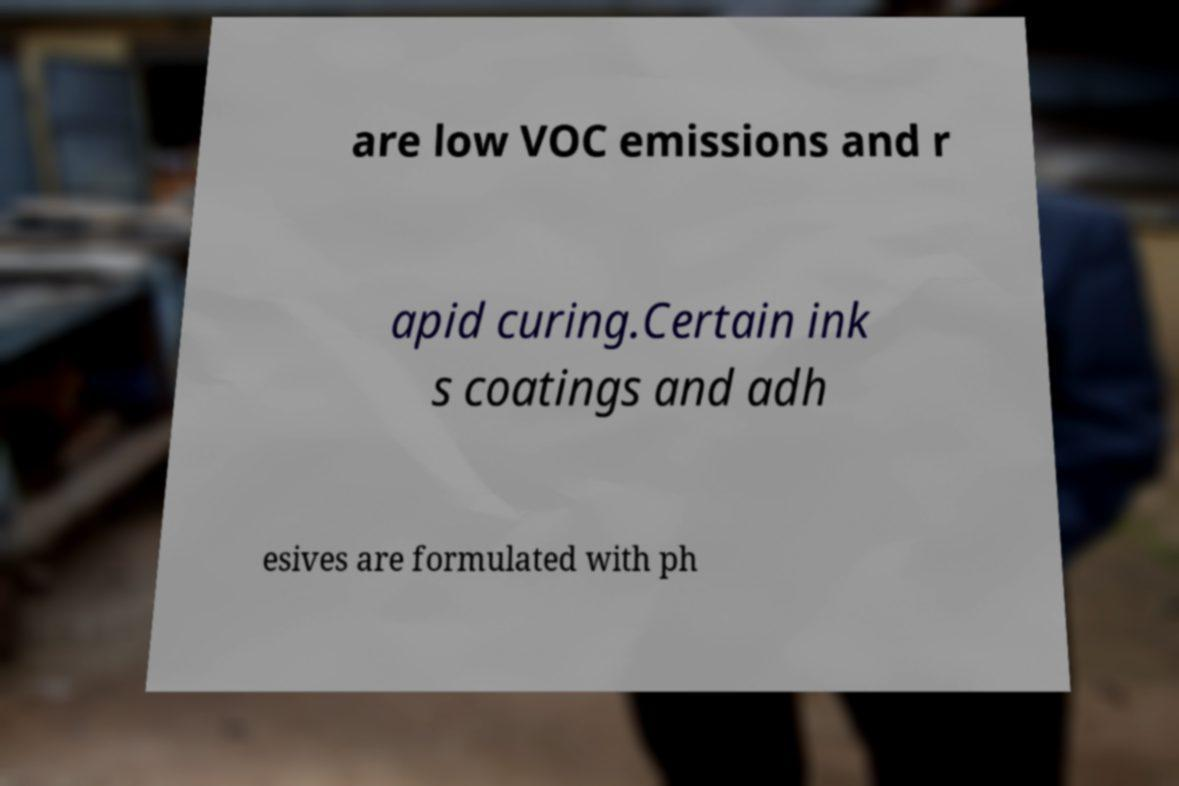Can you read and provide the text displayed in the image?This photo seems to have some interesting text. Can you extract and type it out for me? are low VOC emissions and r apid curing.Certain ink s coatings and adh esives are formulated with ph 